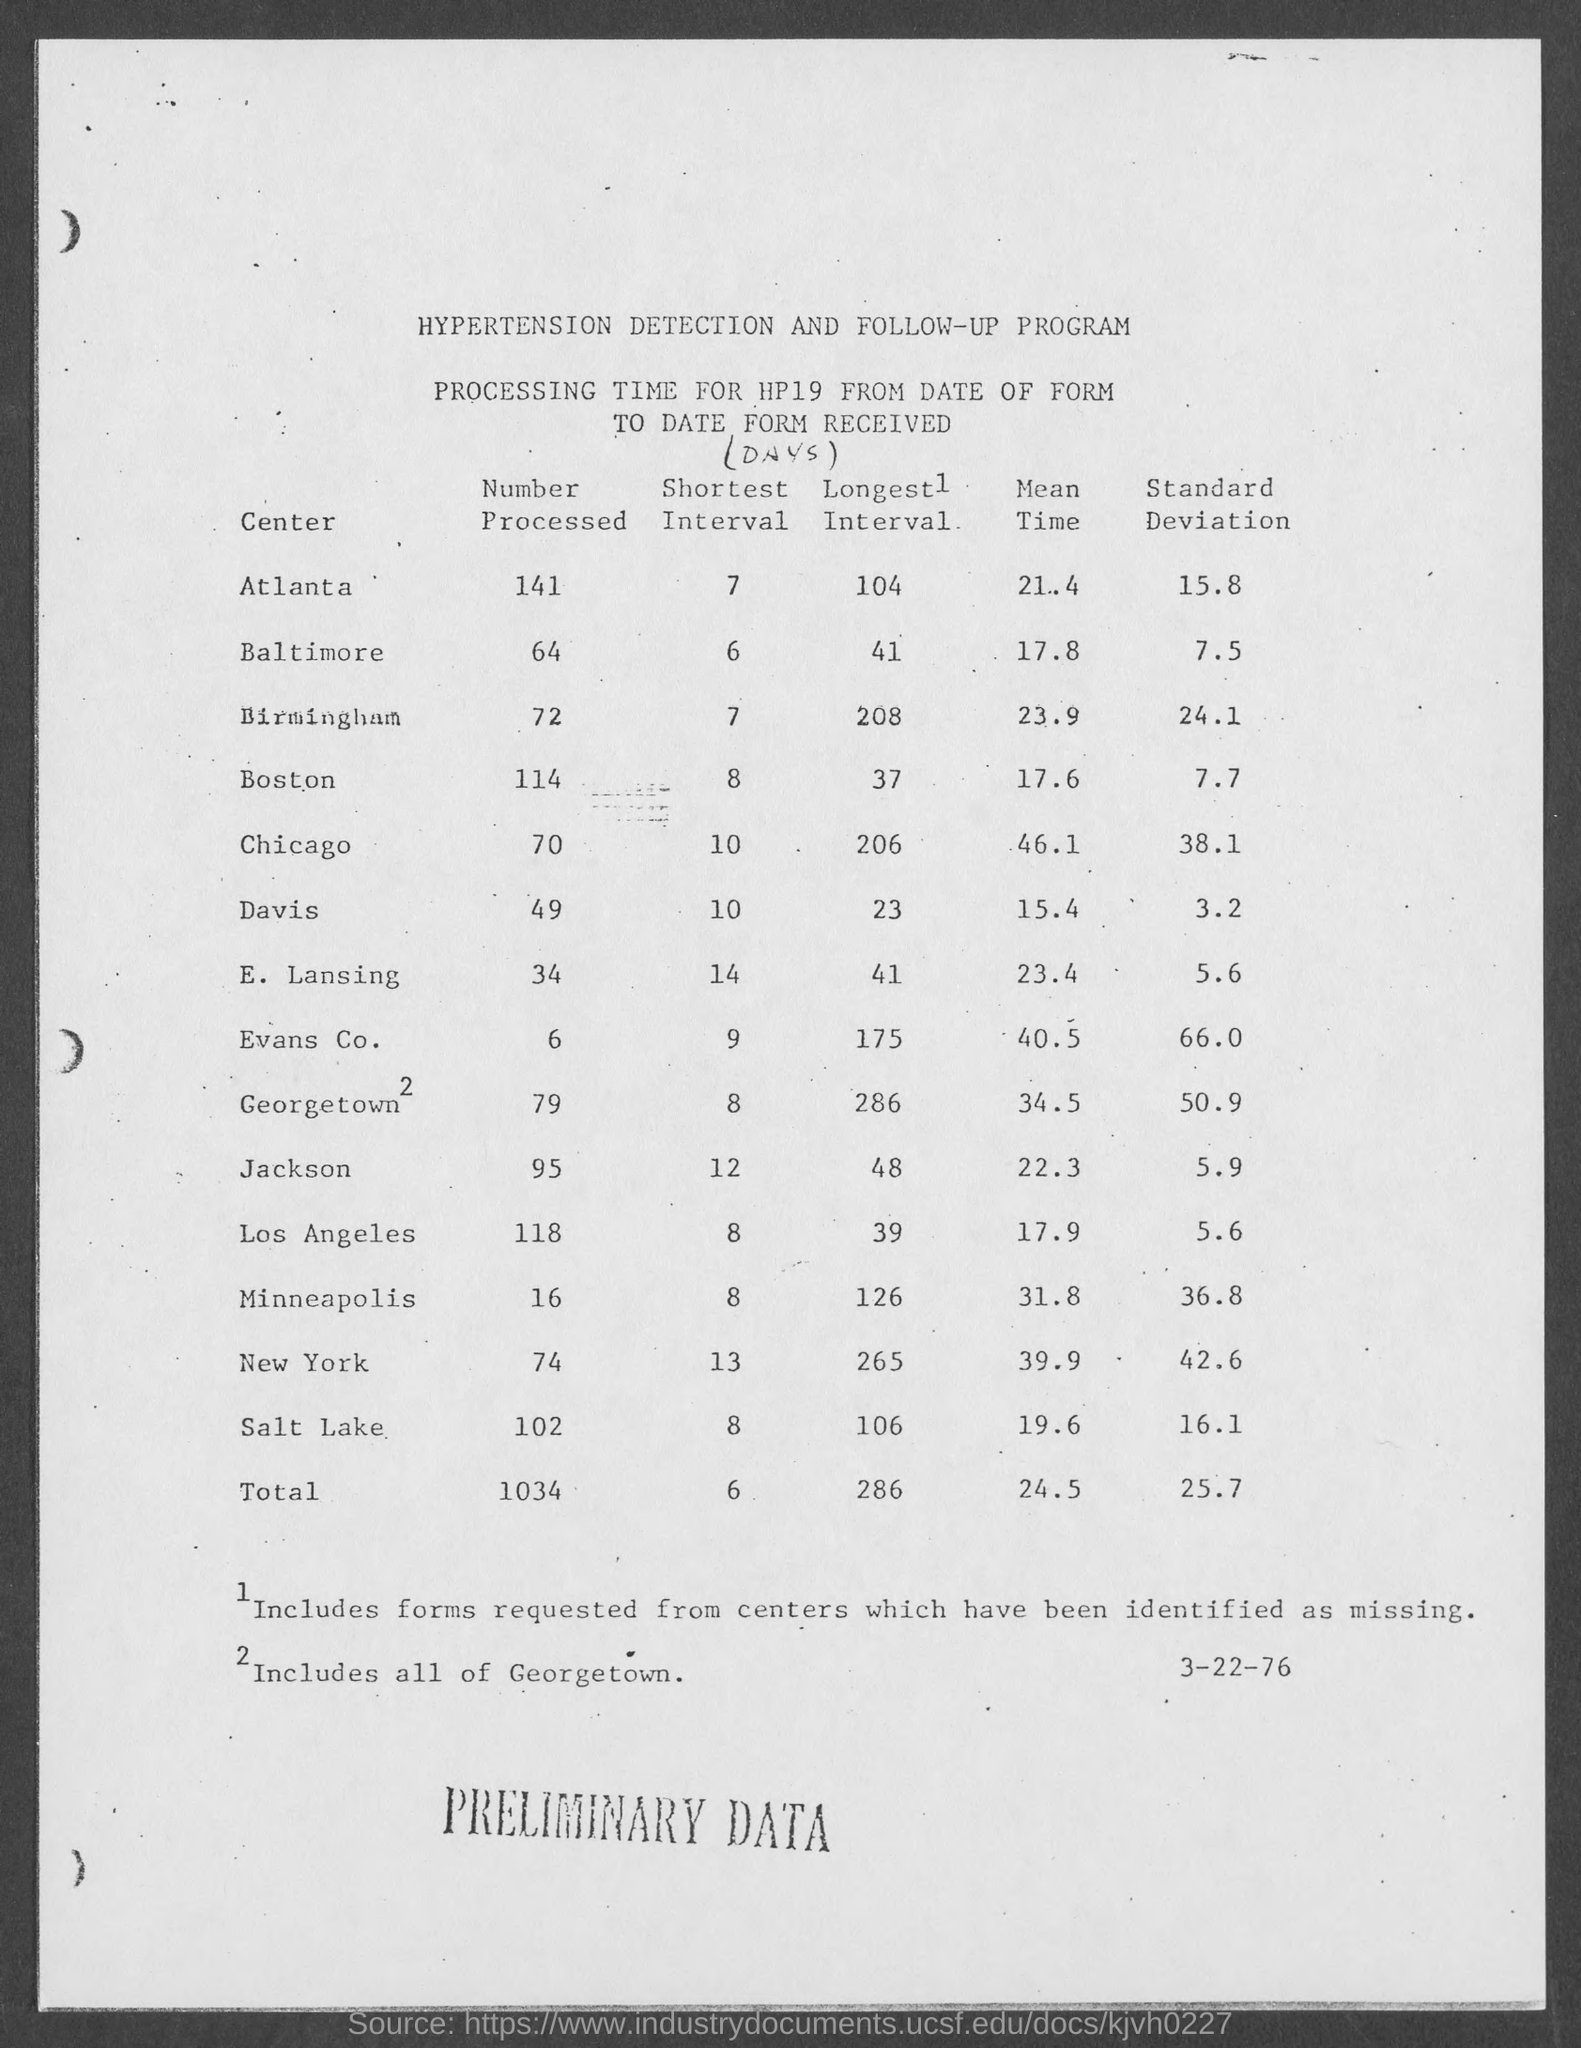What is the title of the program?
Your response must be concise. Hypertension Detection and Follow-Up program. What is the number processed for atlanta?
Make the answer very short. 141. What is the number processed for baltimore ?
Make the answer very short. 64. What is the number processed for birmingham ?
Your answer should be compact. 72. What is the number processed for boston?
Ensure brevity in your answer.  114. What is the mean time for atlanta?
Give a very brief answer. 21.4. What is the standard deviation for atlanta ?
Your response must be concise. 15.8. What is the mean time for baltimore ?
Your answer should be very brief. 17.8. What is the mean time for birmingham ?
Your answer should be compact. 23.9. What is the standard deviation for baltimore ?
Provide a short and direct response. 7.5. 